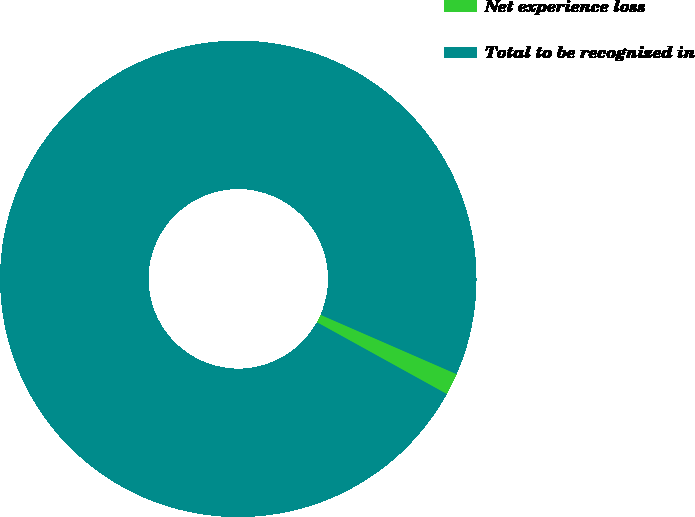Convert chart to OTSL. <chart><loc_0><loc_0><loc_500><loc_500><pie_chart><fcel>Net experience loss<fcel>Total to be recognized in<nl><fcel>1.49%<fcel>98.51%<nl></chart> 